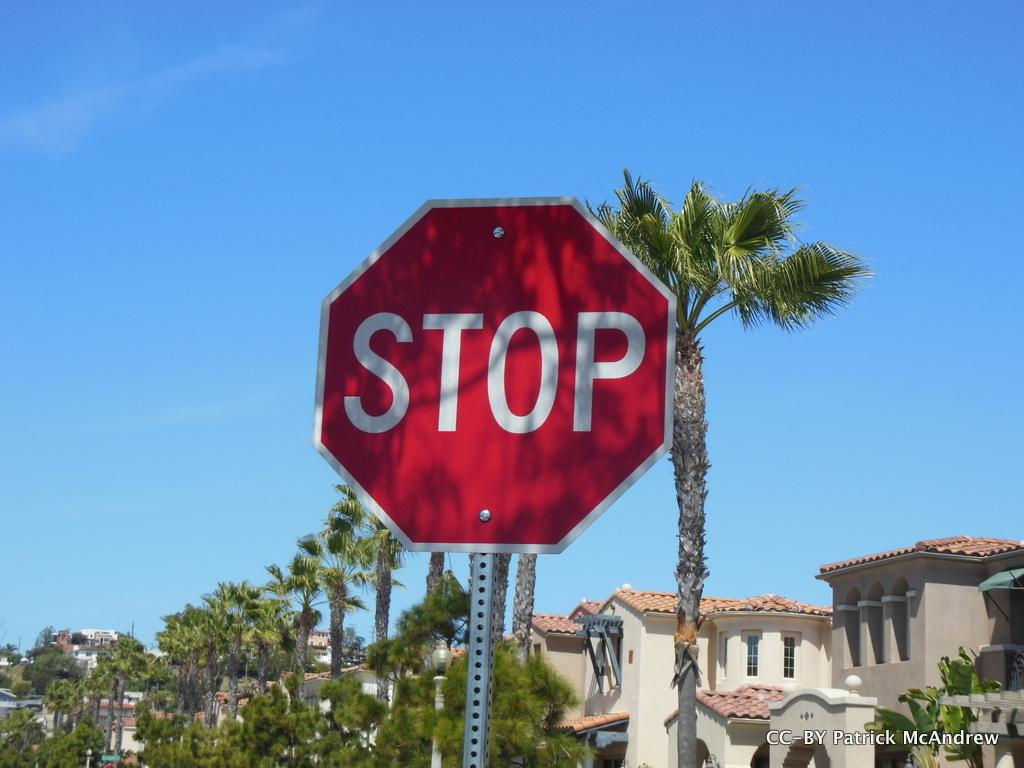<image>
Present a compact description of the photo's key features. a stop sign that s near a building with many trees 